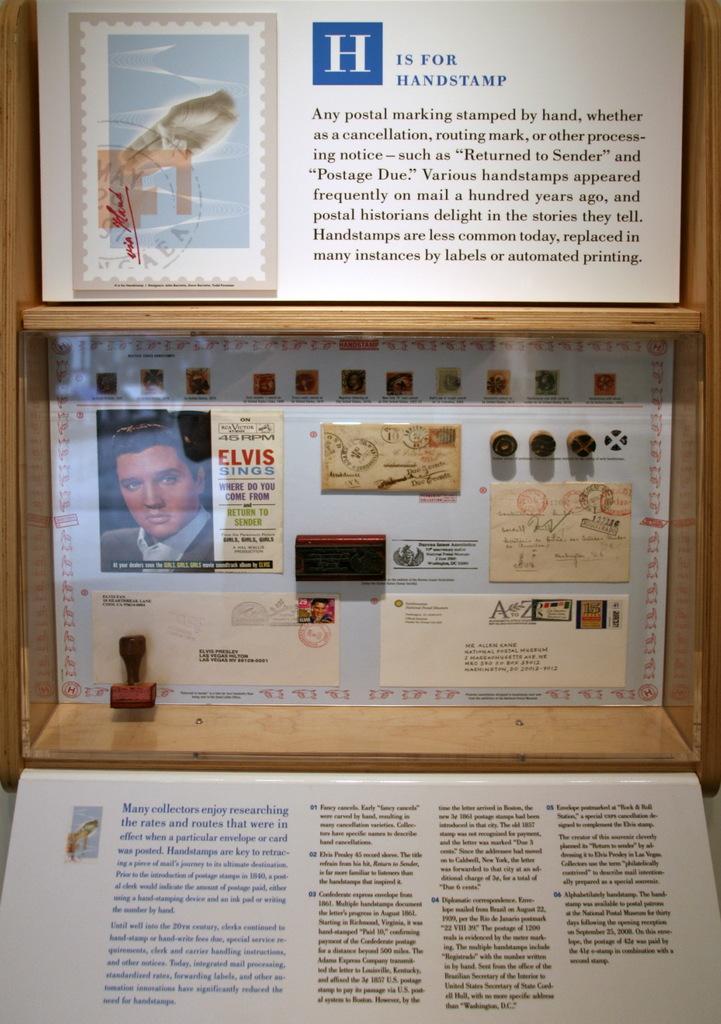Who is the second box honoring?
Your answer should be very brief. Elvis. What letter is in the large blue square?
Offer a terse response. H. 